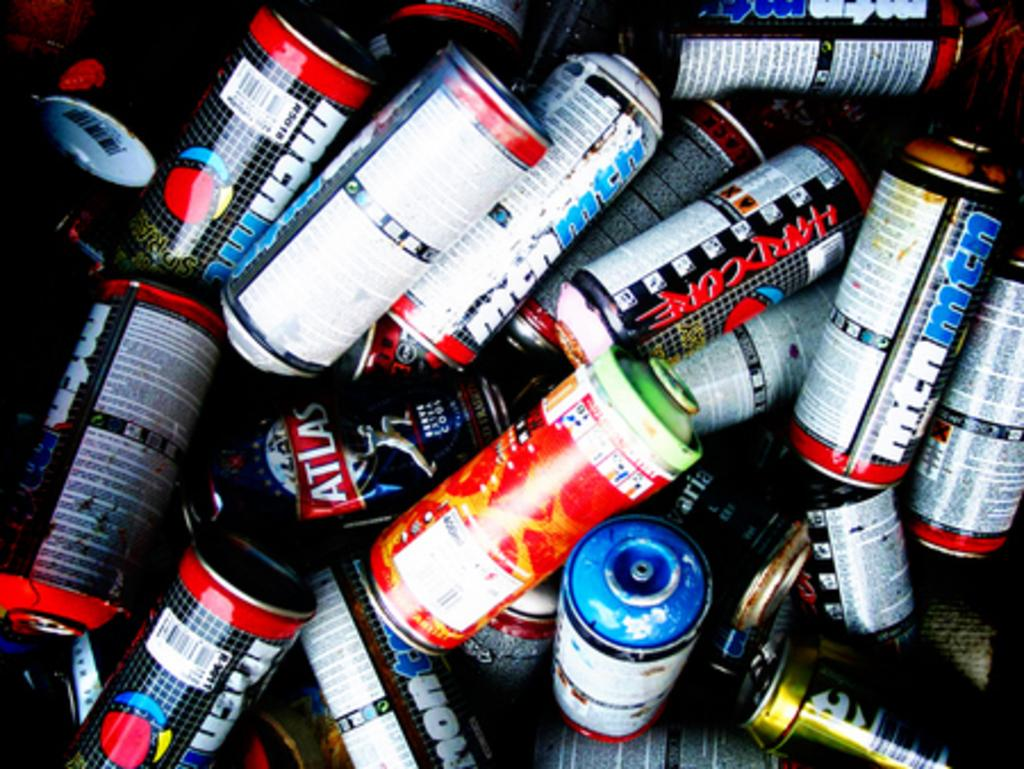<image>
Share a concise interpretation of the image provided. The red rimmed can with red letters says Hard Core. 